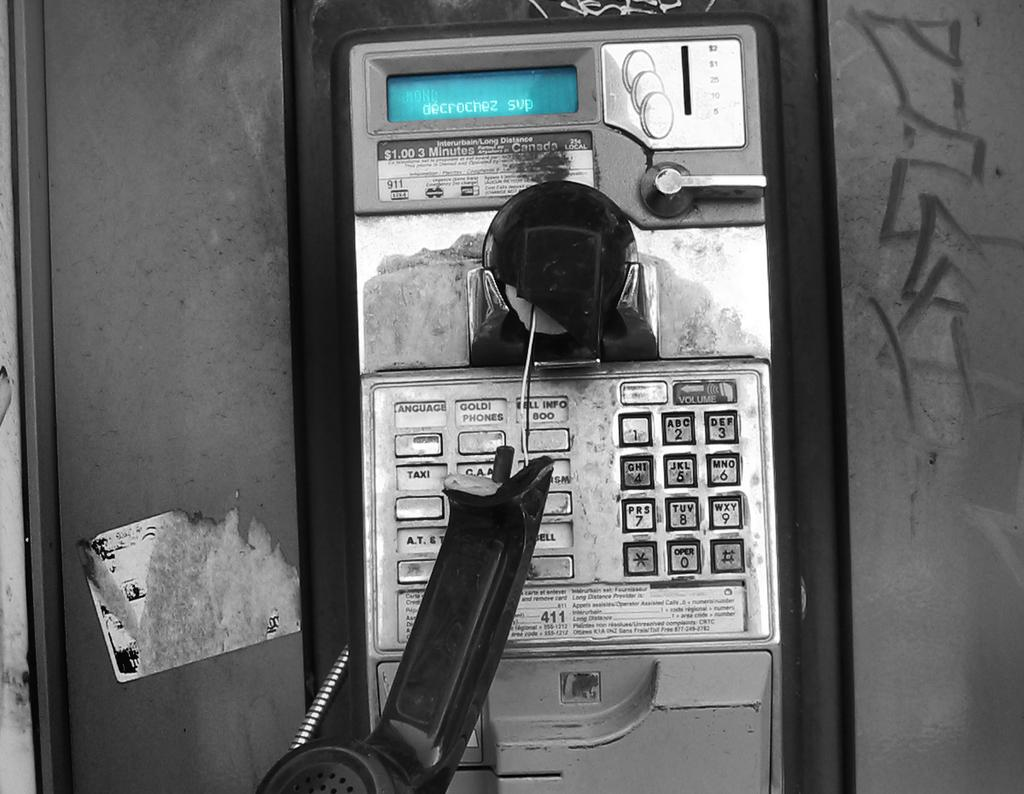Provide a one-sentence caption for the provided image. A broken handset from a payphone that charges $1.00 for 3 minutes. 